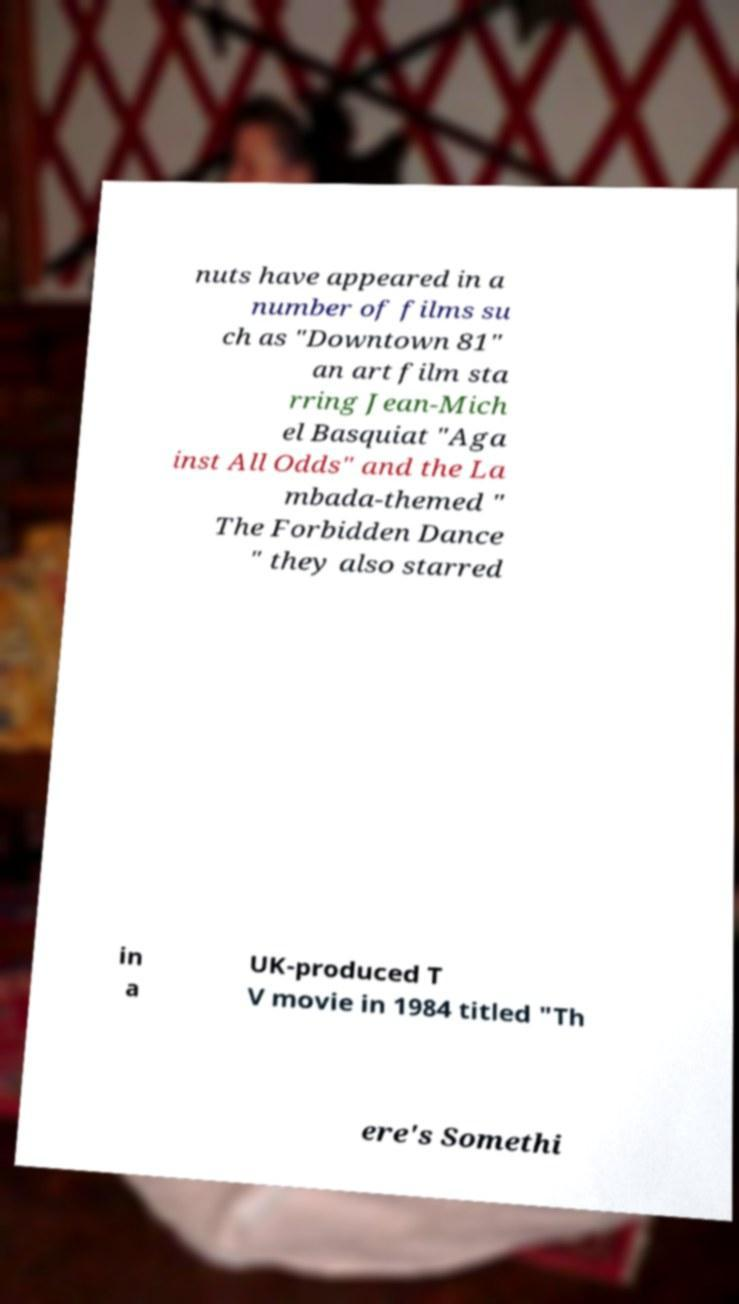Could you assist in decoding the text presented in this image and type it out clearly? nuts have appeared in a number of films su ch as "Downtown 81" an art film sta rring Jean-Mich el Basquiat "Aga inst All Odds" and the La mbada-themed " The Forbidden Dance " they also starred in a UK-produced T V movie in 1984 titled "Th ere's Somethi 